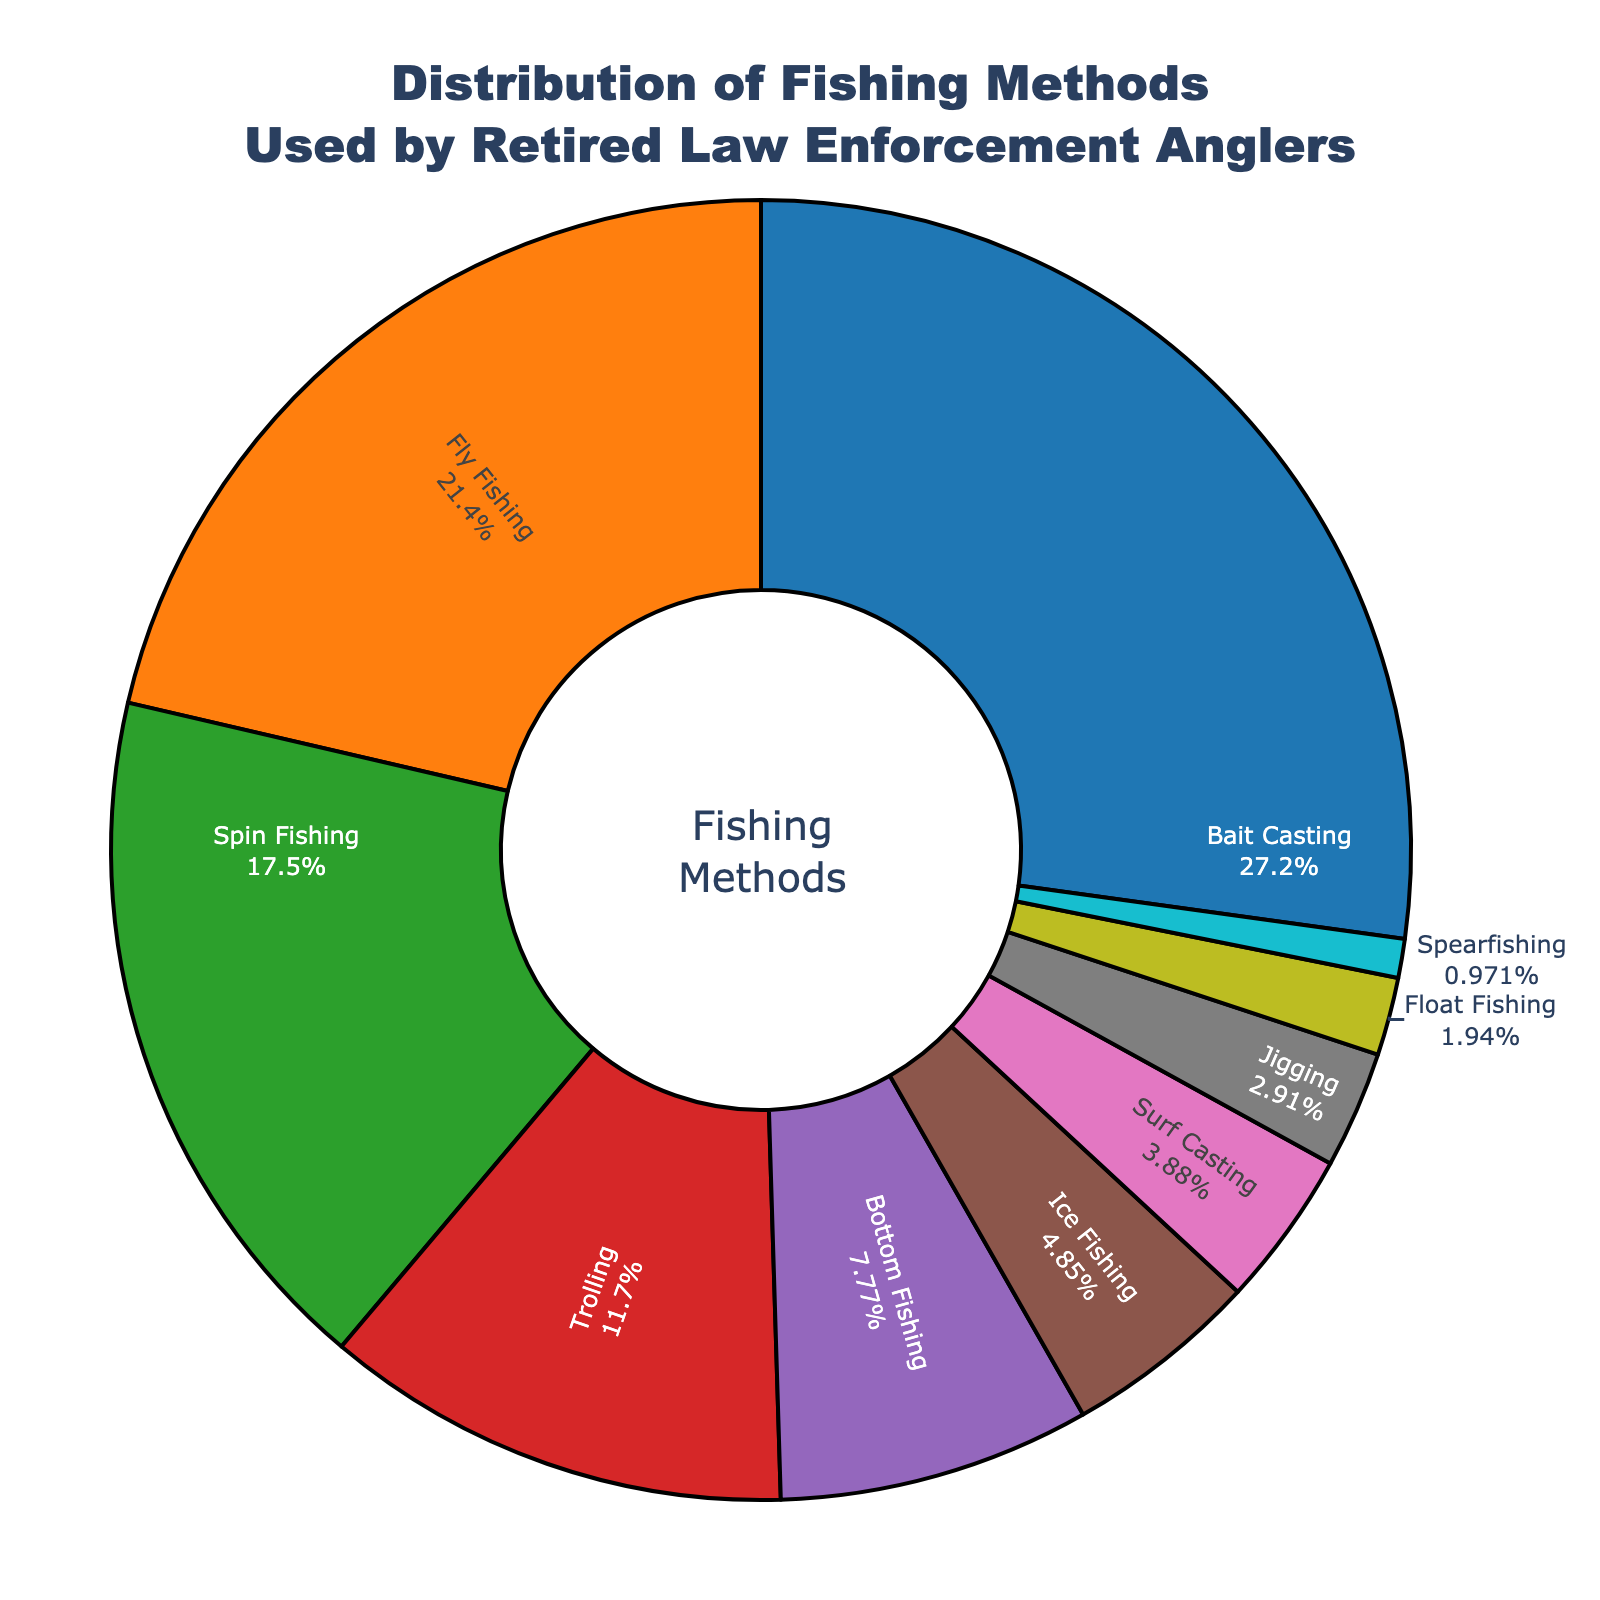What's the most popular fishing method among retired law enforcement anglers? The most popular fishing method is represented by the largest portion of the pie chart. Here, Bait Casting occupies the largest segment.
Answer: Bait Casting Which fishing methods combined make up more than 50% of the total? To answer this, add the percentages of the largest segments until the sum exceeds 50%. Bait Casting (28%) + Fly Fishing (22%) = 50%. These two methods combined make up exactly 50%.
Answer: Bait Casting and Fly Fishing How does Spin Fishing compare to Trolling in terms of usage? Compare the sizes of the segments for Spin Fishing and Trolling. Spin Fishing is 18%, and Trolling is 12%. Spin Fishing has a greater percentage than Trolling.
Answer: Spin Fishing is more popular than Trolling What percentage is represented by the three least popular methods combined? Identify the three smallest segments and sum their percentages. Spearfishing (1%) + Float Fishing (2%) + Jigging (3%) = 1% + 2% + 3% = 6%.
Answer: 6% What colors represent Bait Casting and Fly Fishing in the pie chart? Look for the segments labeled Bait Casting and Fly Fishing and note their colors. Bait Casting is blue, and Fly Fishing is orange.
Answer: Blue and orange What is the combined percentage of Surf Casting and Ice Fishing? Add the percentages of Surf Casting and Ice Fishing. Surf Casting (4%) + Ice Fishing (5%) = 4% + 5% = 9%.
Answer: 9% Which method occupies a larger portion of the pie chart: Bottom Fishing or Jigging? Compare the segments labeled Bottom Fishing and Jigging. Bottom Fishing is 8%, and Jigging is 3%. Bottom Fishing has a larger portion.
Answer: Bottom Fishing If you remove the Fly Fishing segment, what percentage of the chart would be left? Subtract the percentage of Fly Fishing from 100%. 100% - 22% = 78%.
Answer: 78% How much more popular is Spin Fishing compared to Surf Casting? Subtract the percentage of Surf Casting from the percentage of Spin Fishing. 18% - 4% = 14%.
Answer: 14% more What is the difference in popularity between the most and least popular fishing methods? Subtract the percentage of the least popular method (Spearfishing) from the most popular method (Bait Casting). 28% - 1% = 27%.
Answer: 27% 